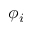Convert formula to latex. <formula><loc_0><loc_0><loc_500><loc_500>\phi _ { i }</formula> 